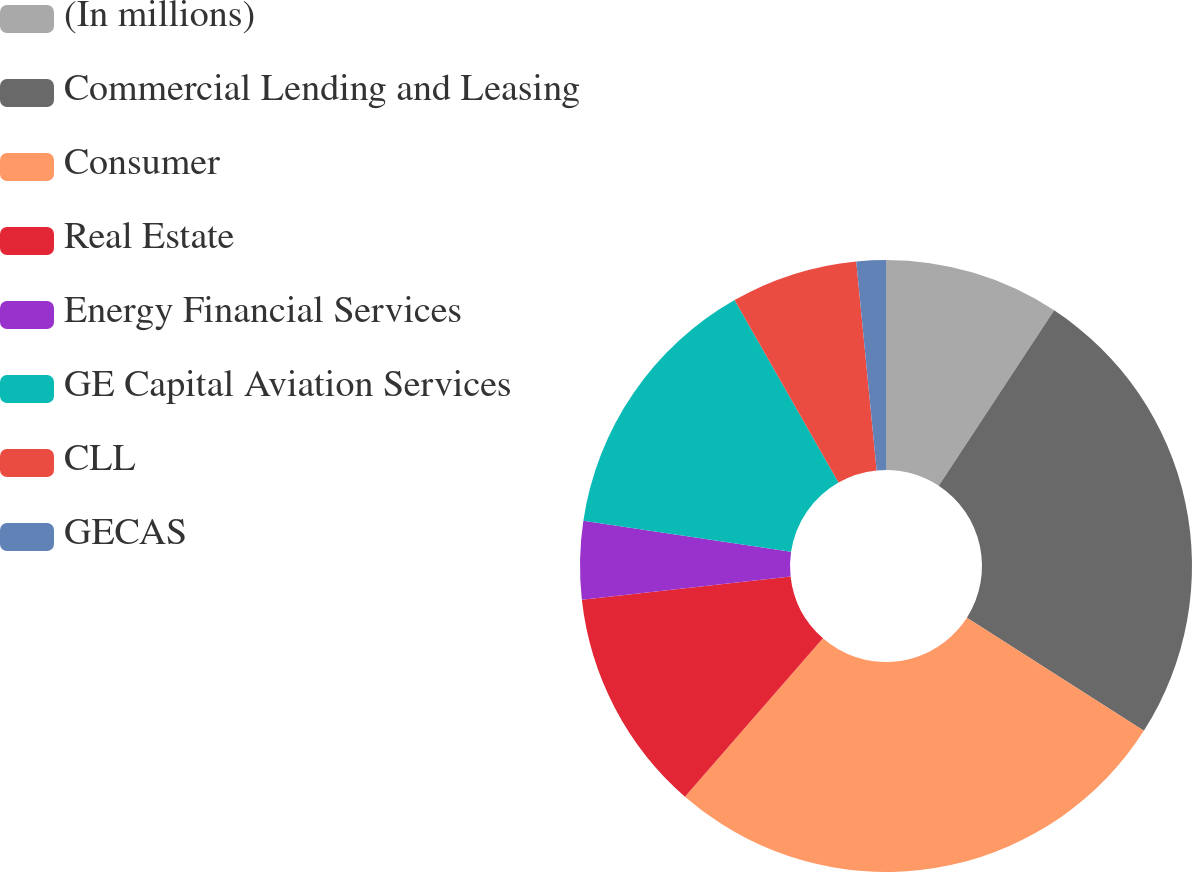Convert chart to OTSL. <chart><loc_0><loc_0><loc_500><loc_500><pie_chart><fcel>(In millions)<fcel>Commercial Lending and Leasing<fcel>Consumer<fcel>Real Estate<fcel>Energy Financial Services<fcel>GE Capital Aviation Services<fcel>CLL<fcel>GECAS<nl><fcel>9.26%<fcel>24.79%<fcel>27.36%<fcel>11.83%<fcel>4.12%<fcel>14.4%<fcel>6.69%<fcel>1.55%<nl></chart> 